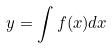<formula> <loc_0><loc_0><loc_500><loc_500>y = \int f ( x ) d x</formula> 